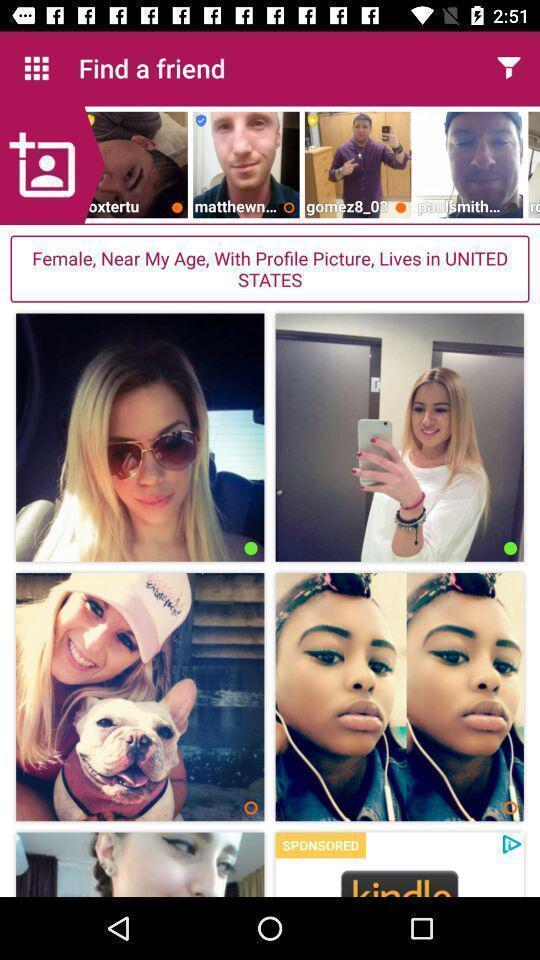Tell me what you see in this picture. Screen displaying multiple users pictures in a dating application. 